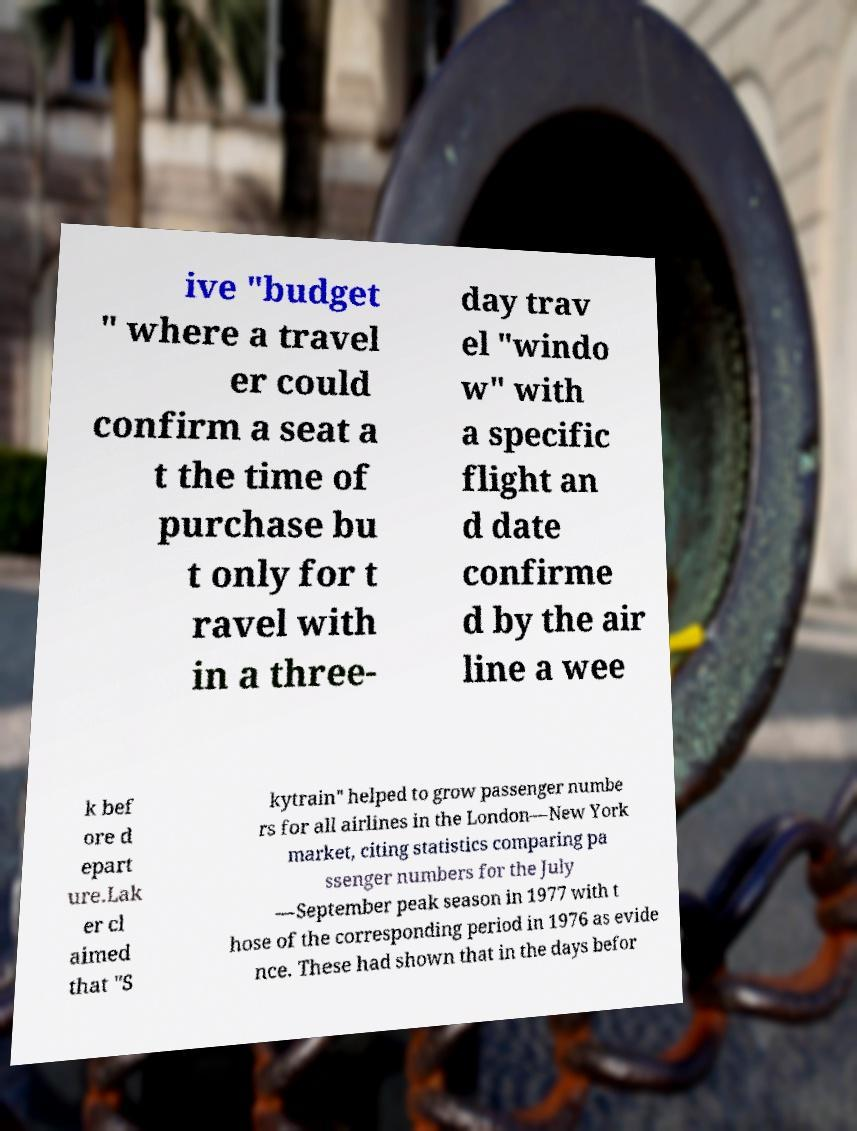Please identify and transcribe the text found in this image. ive "budget " where a travel er could confirm a seat a t the time of purchase bu t only for t ravel with in a three- day trav el "windo w" with a specific flight an d date confirme d by the air line a wee k bef ore d epart ure.Lak er cl aimed that "S kytrain" helped to grow passenger numbe rs for all airlines in the London—New York market, citing statistics comparing pa ssenger numbers for the July —September peak season in 1977 with t hose of the corresponding period in 1976 as evide nce. These had shown that in the days befor 